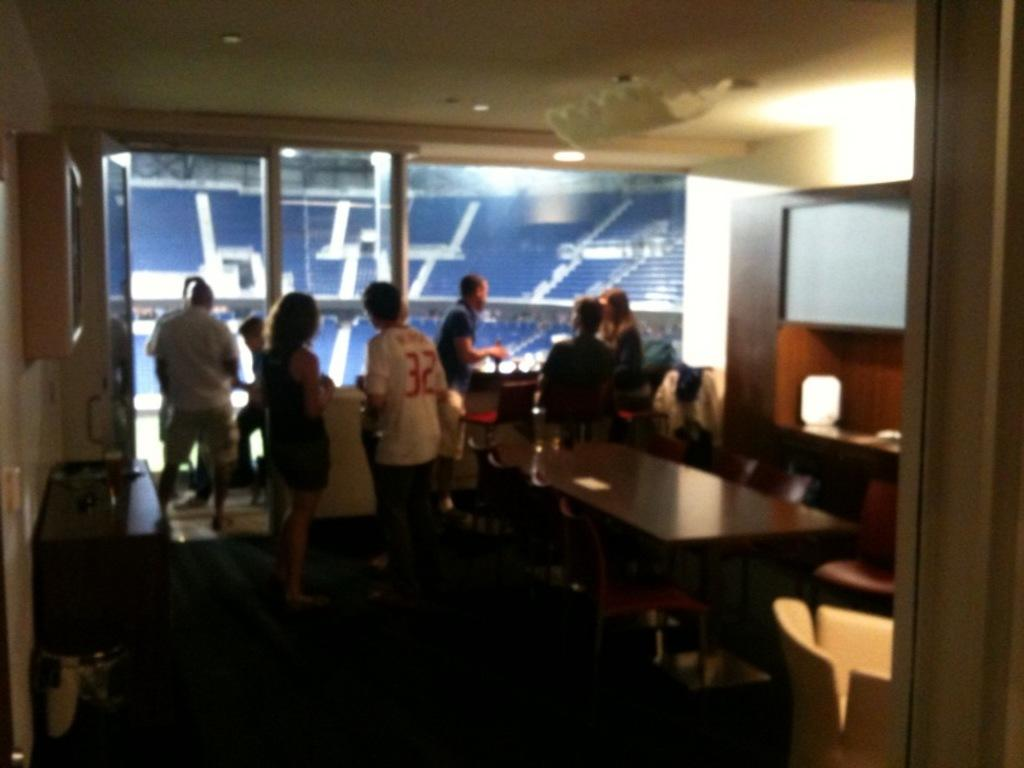What are the people in the image doing? There are people standing and sitting in the image. Where is the image taken? The image appears to be taken in a breakout room. What can be seen in the background of the image? The background of the image is in a stadium. What type of bread can be seen on the bed in the image? There is no bread or bed present in the image. 